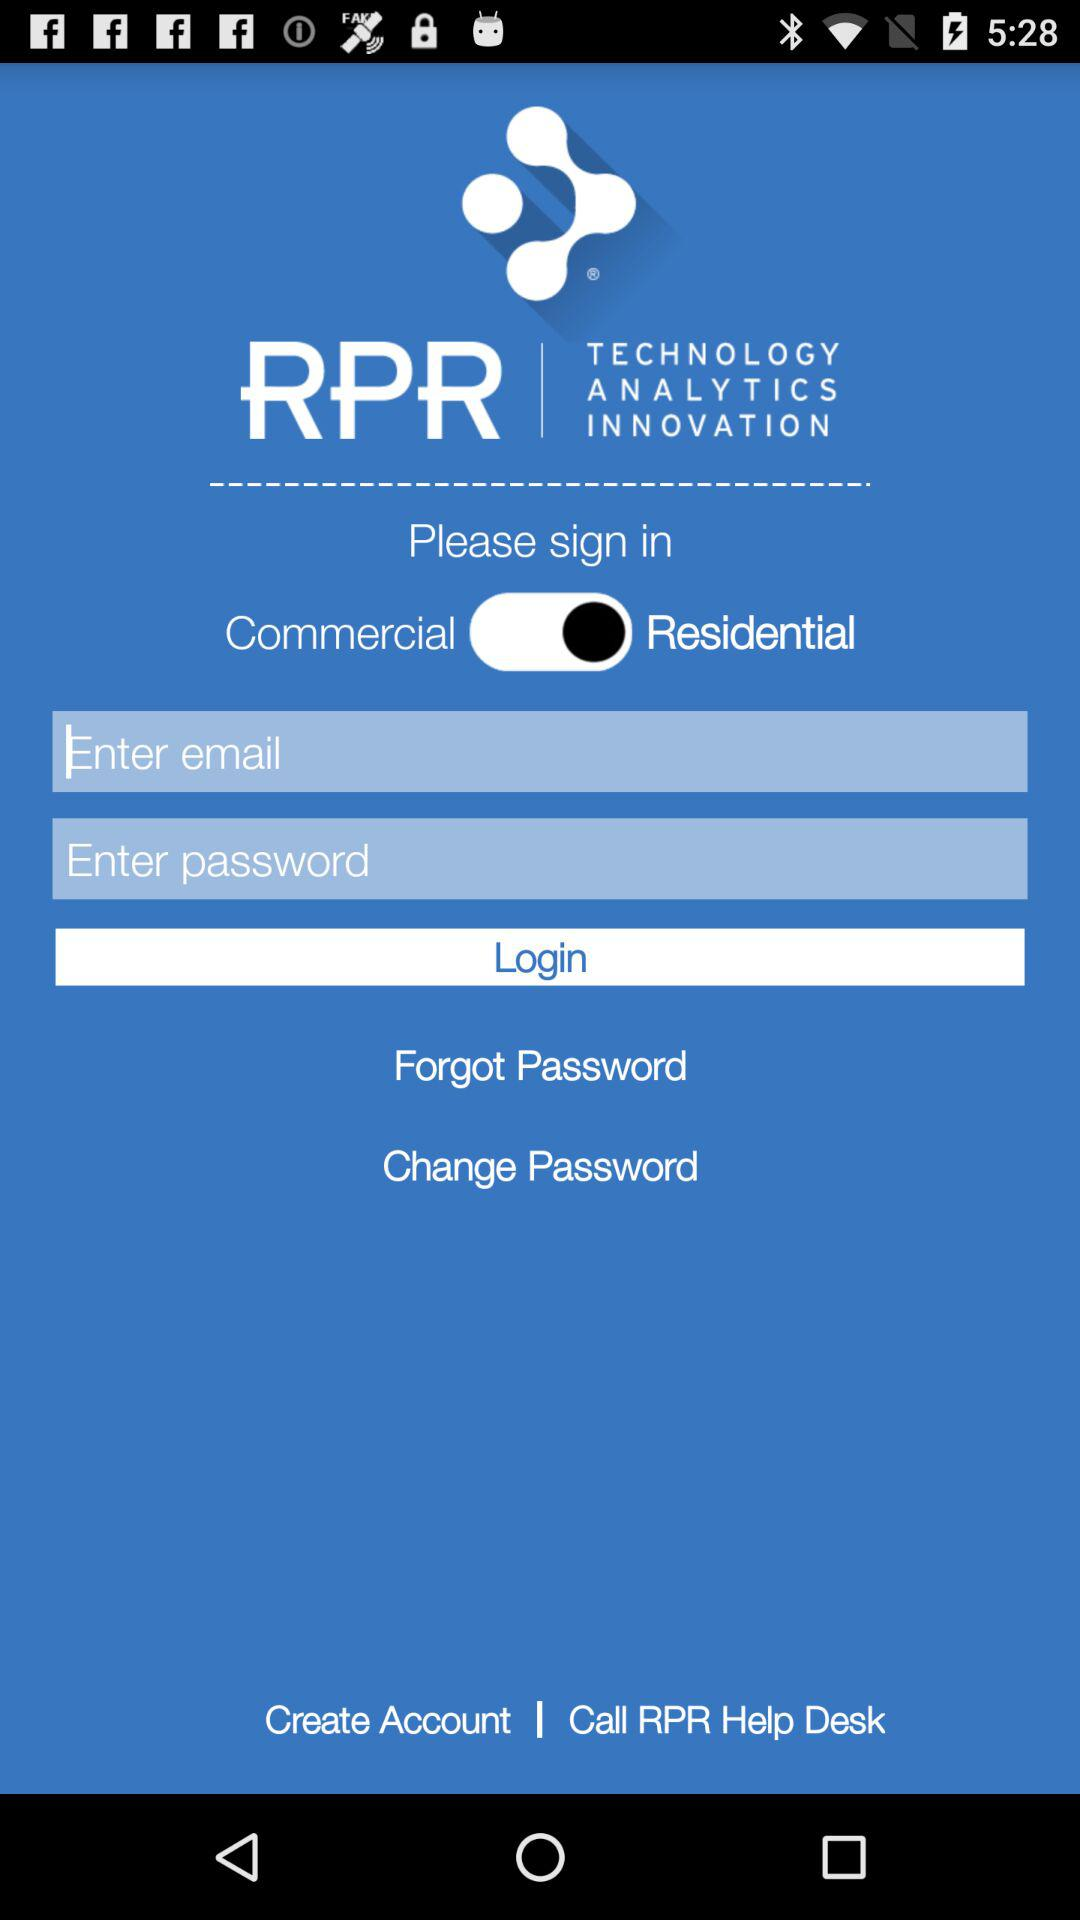What is the name of the application? The name of the application is "RPR". 